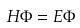Convert formula to latex. <formula><loc_0><loc_0><loc_500><loc_500>H \Phi = E \Phi</formula> 